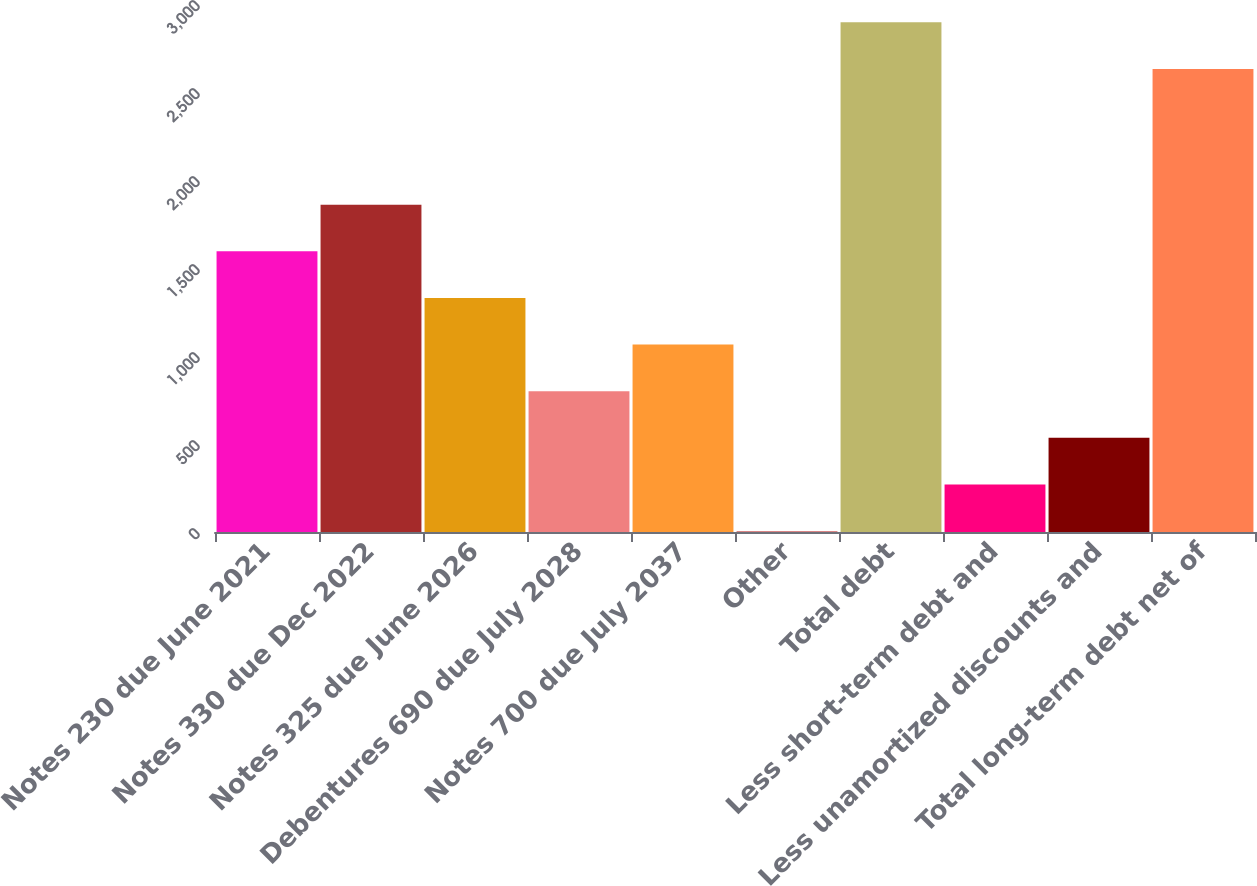Convert chart to OTSL. <chart><loc_0><loc_0><loc_500><loc_500><bar_chart><fcel>Notes 230 due June 2021<fcel>Notes 330 due Dec 2022<fcel>Notes 325 due June 2026<fcel>Debentures 690 due July 2028<fcel>Notes 700 due July 2037<fcel>Other<fcel>Total debt<fcel>Less short-term debt and<fcel>Less unamortized discounts and<fcel>Total long-term debt net of<nl><fcel>1594.9<fcel>1859.9<fcel>1329.9<fcel>799.9<fcel>1064.9<fcel>4.9<fcel>2895.6<fcel>269.9<fcel>534.9<fcel>2630.6<nl></chart> 